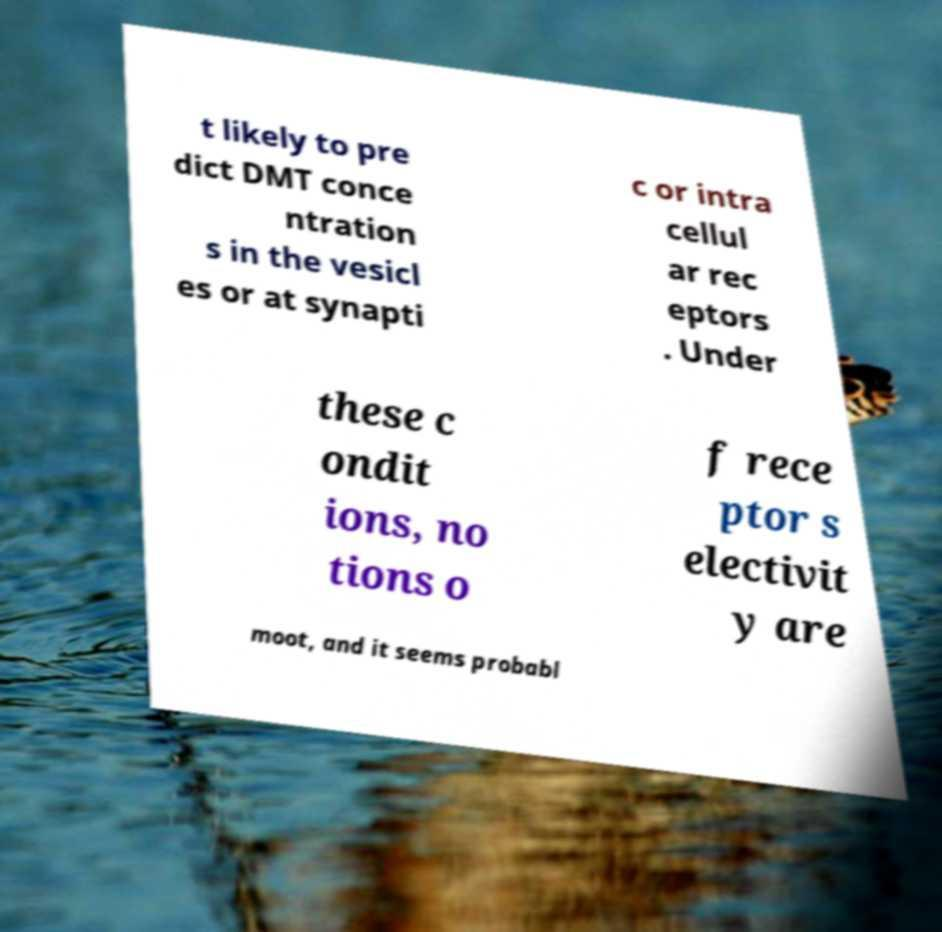What messages or text are displayed in this image? I need them in a readable, typed format. t likely to pre dict DMT conce ntration s in the vesicl es or at synapti c or intra cellul ar rec eptors . Under these c ondit ions, no tions o f rece ptor s electivit y are moot, and it seems probabl 